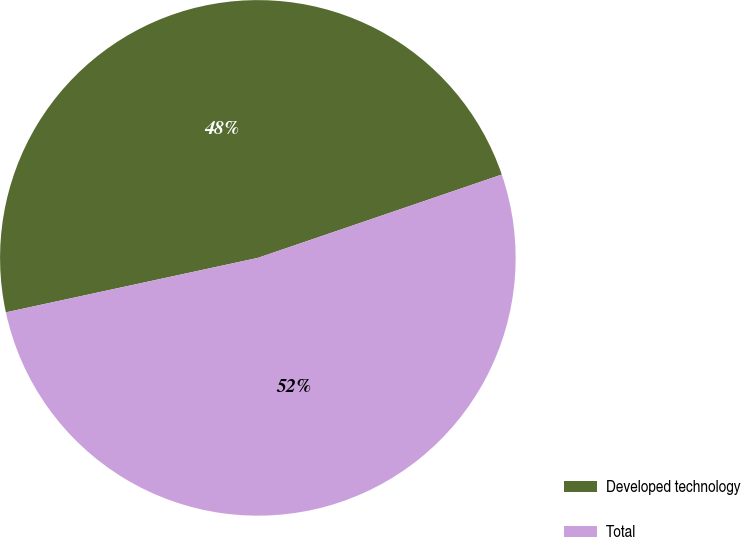Convert chart to OTSL. <chart><loc_0><loc_0><loc_500><loc_500><pie_chart><fcel>Developed technology<fcel>Total<nl><fcel>48.15%<fcel>51.85%<nl></chart> 